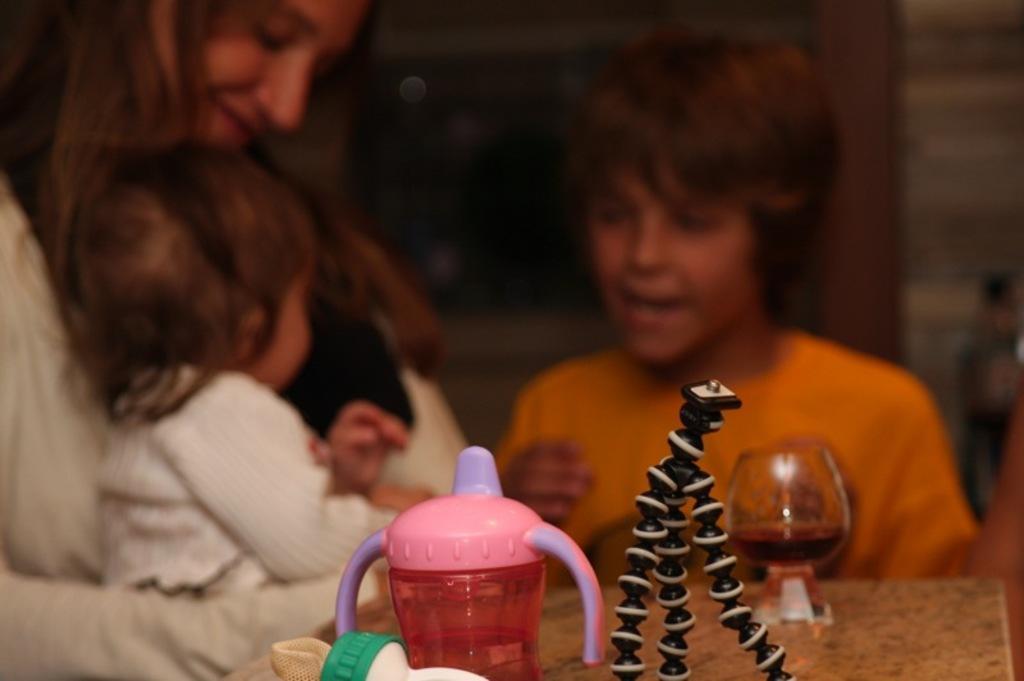In one or two sentences, can you explain what this image depicts? There is a glass, water bottle and other objects in the foreground area of the image, there are people in the background. 